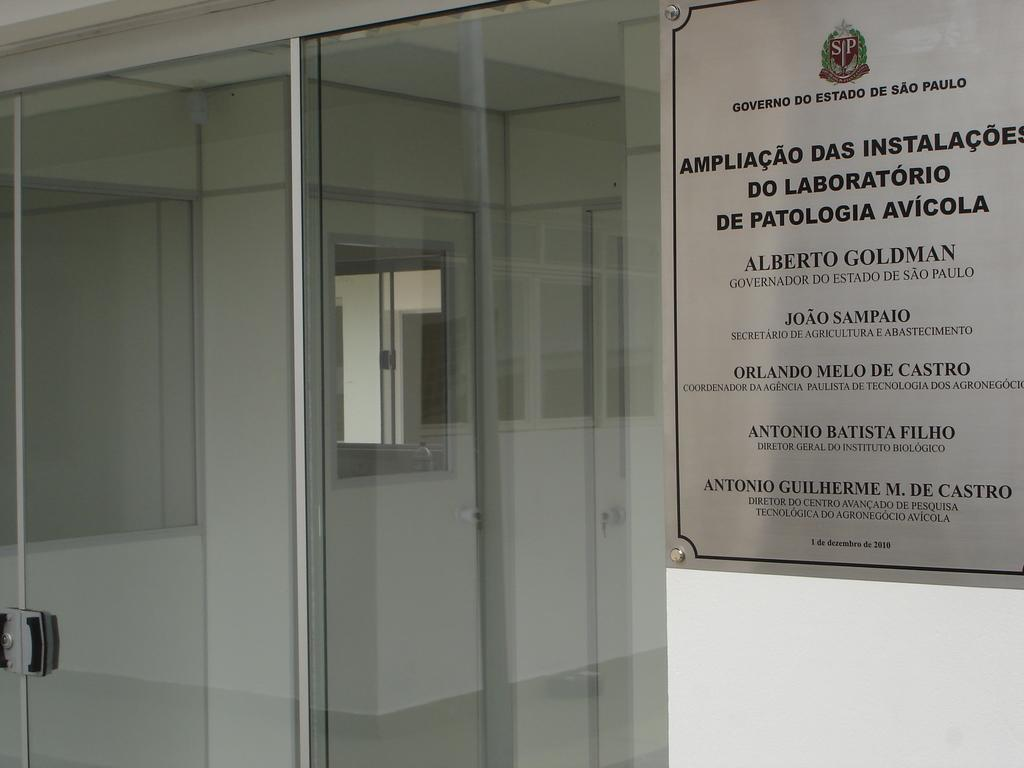Provide a one-sentence caption for the provided image. A sign mentions several people, including Alberto GOldman and Joao Sampaio. 